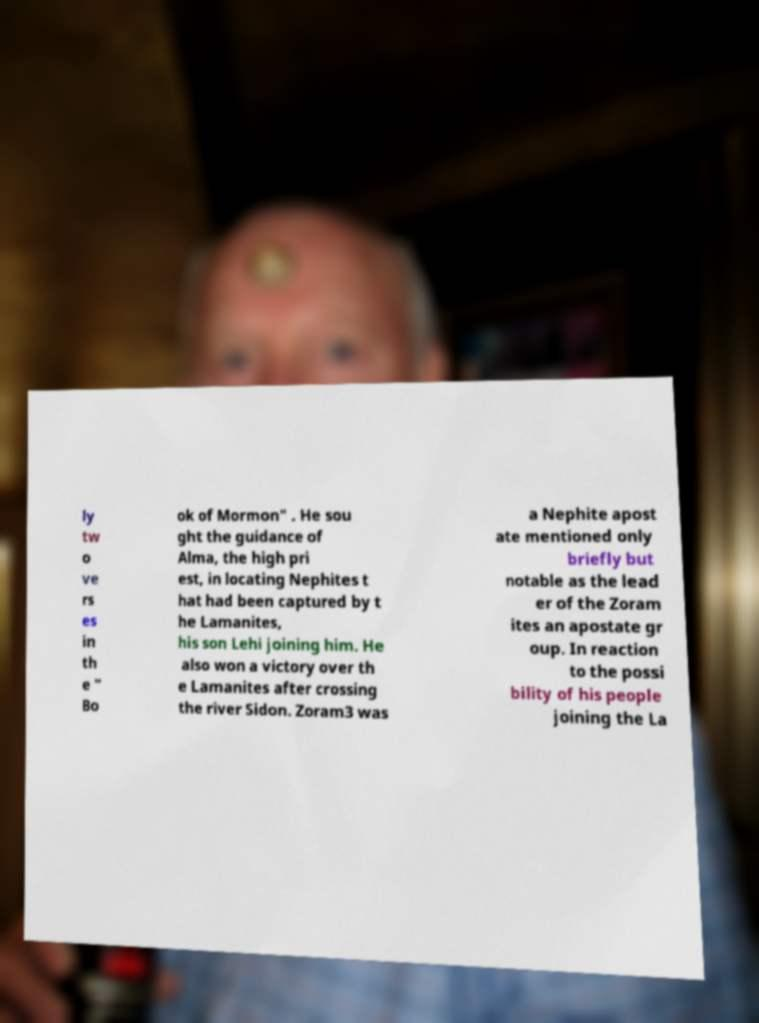Can you accurately transcribe the text from the provided image for me? ly tw o ve rs es in th e " Bo ok of Mormon" . He sou ght the guidance of Alma, the high pri est, in locating Nephites t hat had been captured by t he Lamanites, his son Lehi joining him. He also won a victory over th e Lamanites after crossing the river Sidon. Zoram3 was a Nephite apost ate mentioned only briefly but notable as the lead er of the Zoram ites an apostate gr oup. In reaction to the possi bility of his people joining the La 